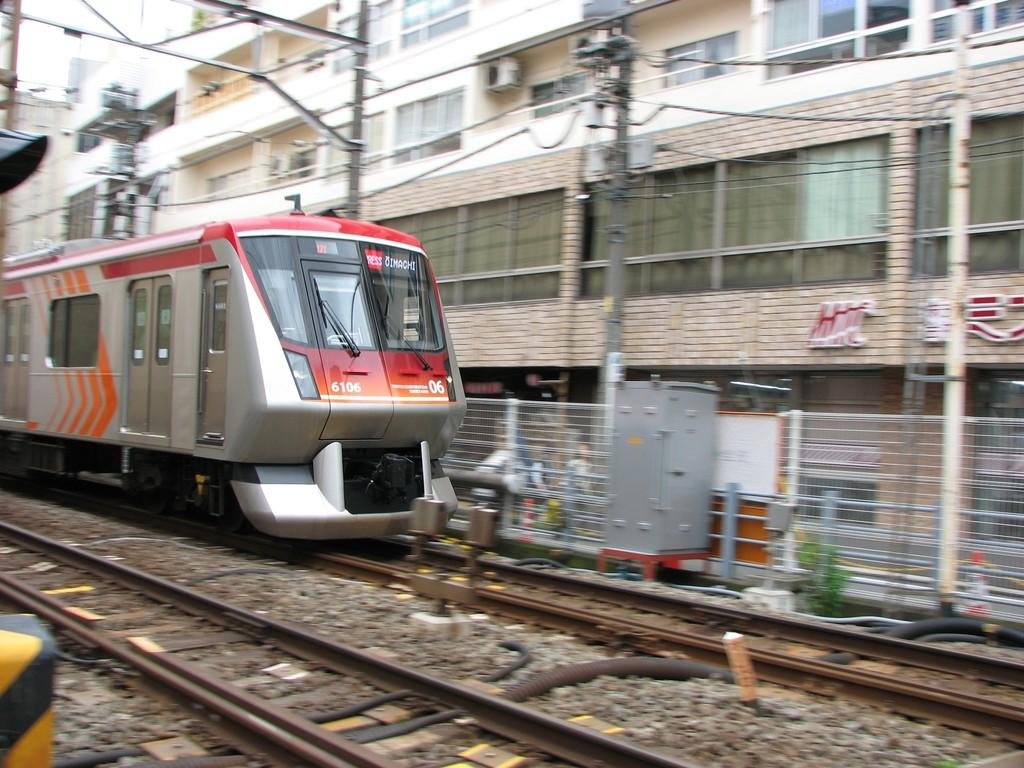What is located on the track in the image? There is a train on the track in the image. What type of object is the metal box in the image? There is a metal box in the image, but its specific purpose is not clear. What are the poles in the image used for? The poles in the image are likely used to support the wires. What can be seen connected to the poles in the image? There are wires connected to the poles in the image. What type of barrier is present in the image? There is a fence in the image. What type of structures are visible in the background of the image? There are buildings in the image. Where are the sister and the beds located in the image? There is no sister or beds present in the image. What type of coil is wrapped around the train in the image? There is no coil present in the image; the train is on the track. 